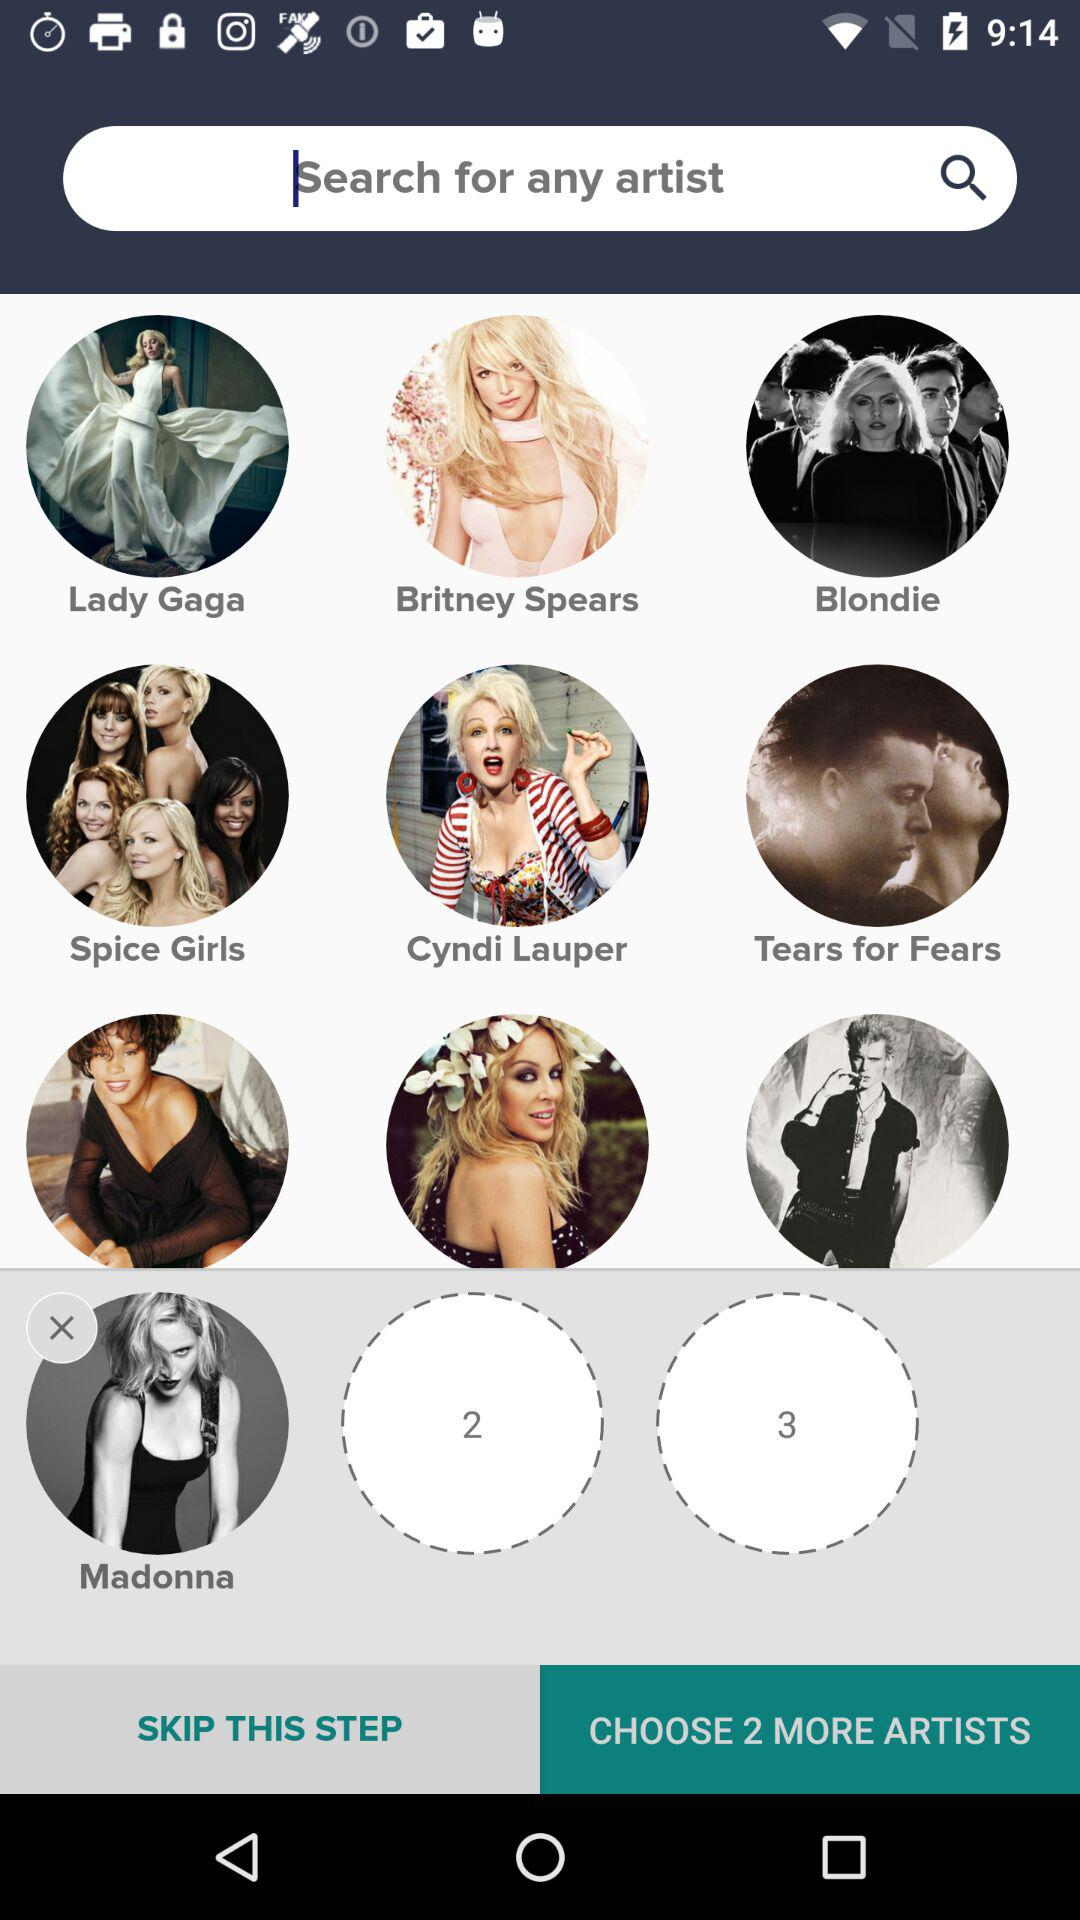How many more artists can be chosen? The number of more artists that can be chosen is 2. 